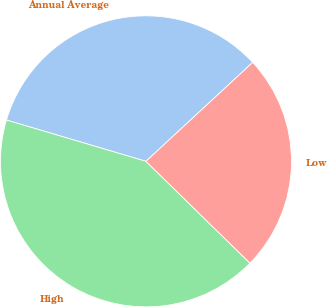Convert chart. <chart><loc_0><loc_0><loc_500><loc_500><pie_chart><fcel>Annual Average<fcel>High<fcel>Low<nl><fcel>33.52%<fcel>42.25%<fcel>24.23%<nl></chart> 